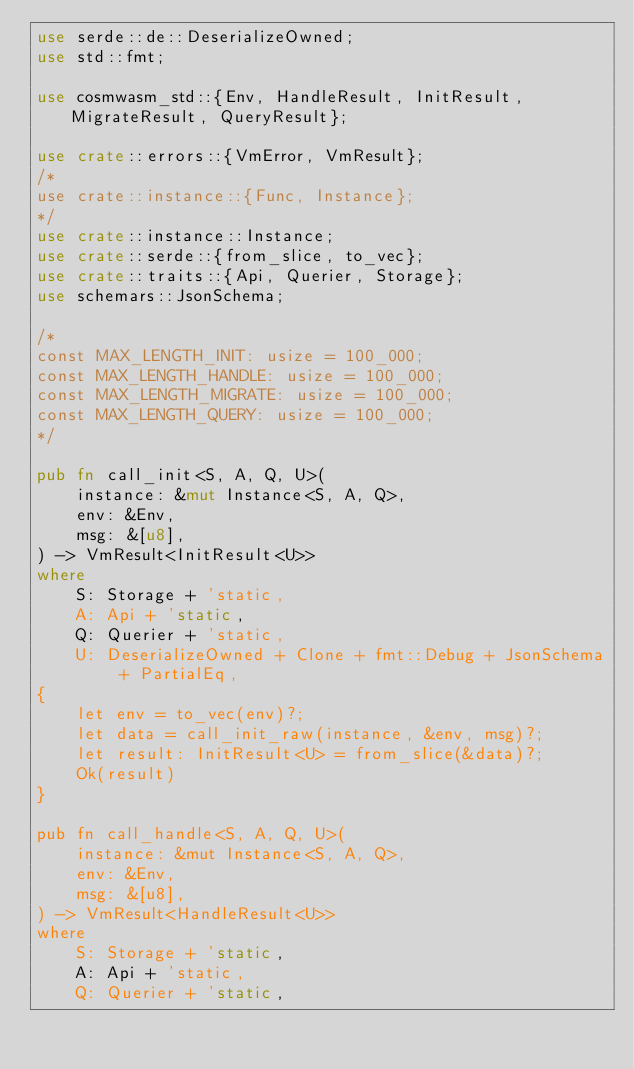Convert code to text. <code><loc_0><loc_0><loc_500><loc_500><_Rust_>use serde::de::DeserializeOwned;
use std::fmt;

use cosmwasm_std::{Env, HandleResult, InitResult, MigrateResult, QueryResult};

use crate::errors::{VmError, VmResult};
/*
use crate::instance::{Func, Instance};
*/
use crate::instance::Instance;
use crate::serde::{from_slice, to_vec};
use crate::traits::{Api, Querier, Storage};
use schemars::JsonSchema;

/*
const MAX_LENGTH_INIT: usize = 100_000;
const MAX_LENGTH_HANDLE: usize = 100_000;
const MAX_LENGTH_MIGRATE: usize = 100_000;
const MAX_LENGTH_QUERY: usize = 100_000;
*/

pub fn call_init<S, A, Q, U>(
    instance: &mut Instance<S, A, Q>,
    env: &Env,
    msg: &[u8],
) -> VmResult<InitResult<U>>
where
    S: Storage + 'static,
    A: Api + 'static,
    Q: Querier + 'static,
    U: DeserializeOwned + Clone + fmt::Debug + JsonSchema + PartialEq,
{
    let env = to_vec(env)?;
    let data = call_init_raw(instance, &env, msg)?;
    let result: InitResult<U> = from_slice(&data)?;
    Ok(result)
}

pub fn call_handle<S, A, Q, U>(
    instance: &mut Instance<S, A, Q>,
    env: &Env,
    msg: &[u8],
) -> VmResult<HandleResult<U>>
where
    S: Storage + 'static,
    A: Api + 'static,
    Q: Querier + 'static,</code> 